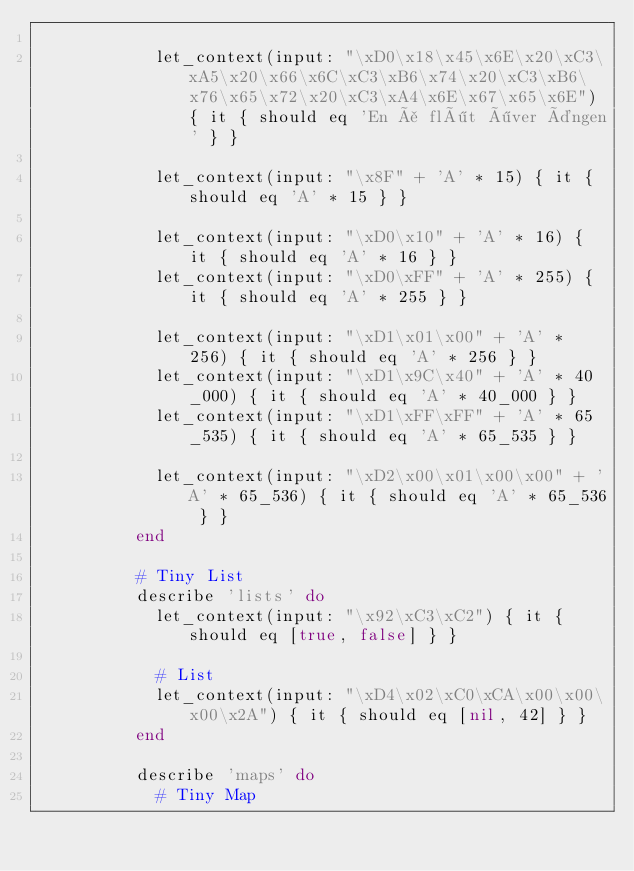Convert code to text. <code><loc_0><loc_0><loc_500><loc_500><_Ruby_>
            let_context(input: "\xD0\x18\x45\x6E\x20\xC3\xA5\x20\x66\x6C\xC3\xB6\x74\x20\xC3\xB6\x76\x65\x72\x20\xC3\xA4\x6E\x67\x65\x6E") { it { should eq 'En å flöt över ängen' } }

            let_context(input: "\x8F" + 'A' * 15) { it { should eq 'A' * 15 } }

            let_context(input: "\xD0\x10" + 'A' * 16) { it { should eq 'A' * 16 } }
            let_context(input: "\xD0\xFF" + 'A' * 255) { it { should eq 'A' * 255 } }

            let_context(input: "\xD1\x01\x00" + 'A' * 256) { it { should eq 'A' * 256 } }
            let_context(input: "\xD1\x9C\x40" + 'A' * 40_000) { it { should eq 'A' * 40_000 } }
            let_context(input: "\xD1\xFF\xFF" + 'A' * 65_535) { it { should eq 'A' * 65_535 } }

            let_context(input: "\xD2\x00\x01\x00\x00" + 'A' * 65_536) { it { should eq 'A' * 65_536 } }
          end

          # Tiny List
          describe 'lists' do
            let_context(input: "\x92\xC3\xC2") { it { should eq [true, false] } }

            # List
            let_context(input: "\xD4\x02\xC0\xCA\x00\x00\x00\x2A") { it { should eq [nil, 42] } }
          end

          describe 'maps' do
            # Tiny Map</code> 